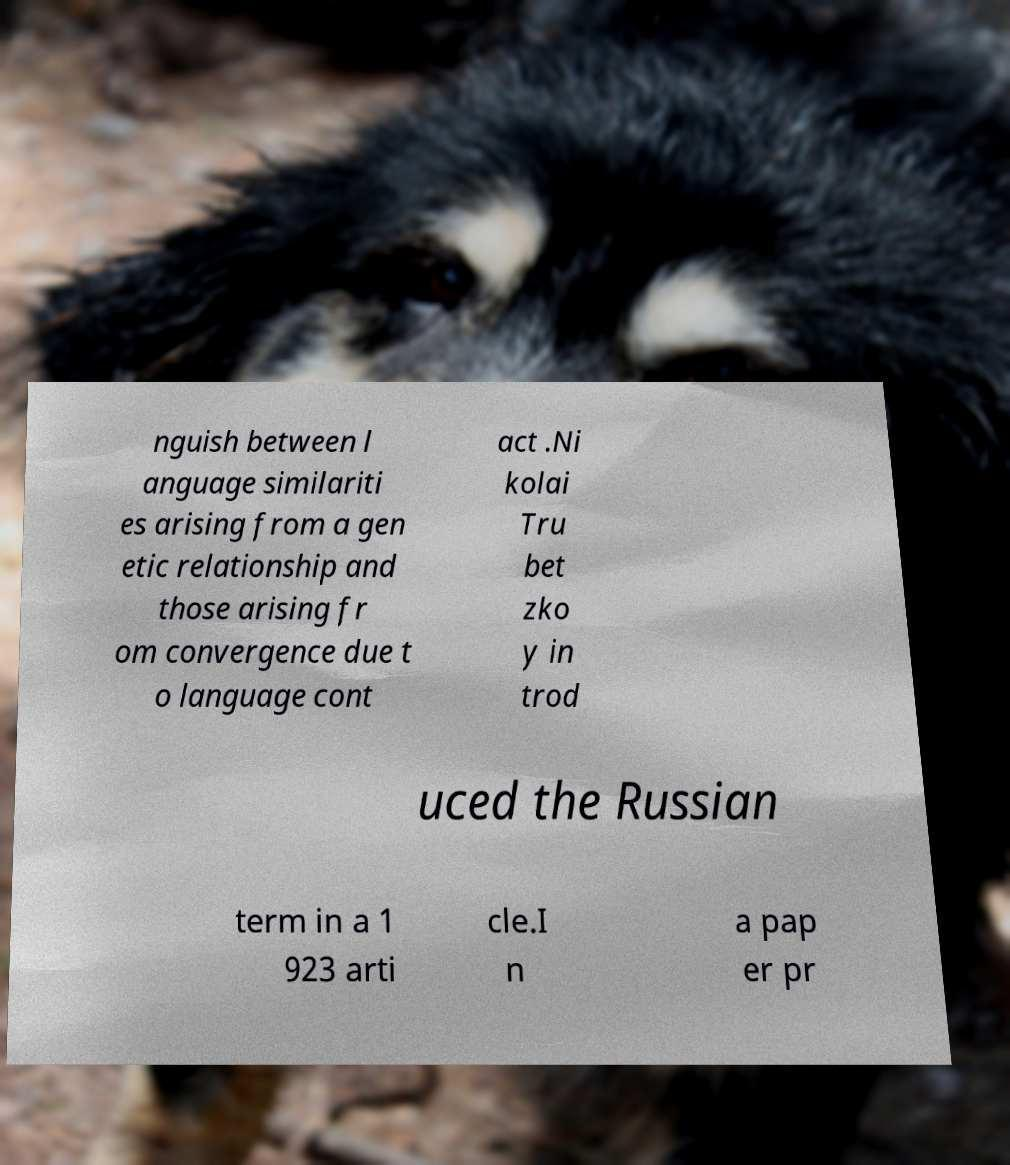Could you assist in decoding the text presented in this image and type it out clearly? nguish between l anguage similariti es arising from a gen etic relationship and those arising fr om convergence due t o language cont act .Ni kolai Tru bet zko y in trod uced the Russian term in a 1 923 arti cle.I n a pap er pr 